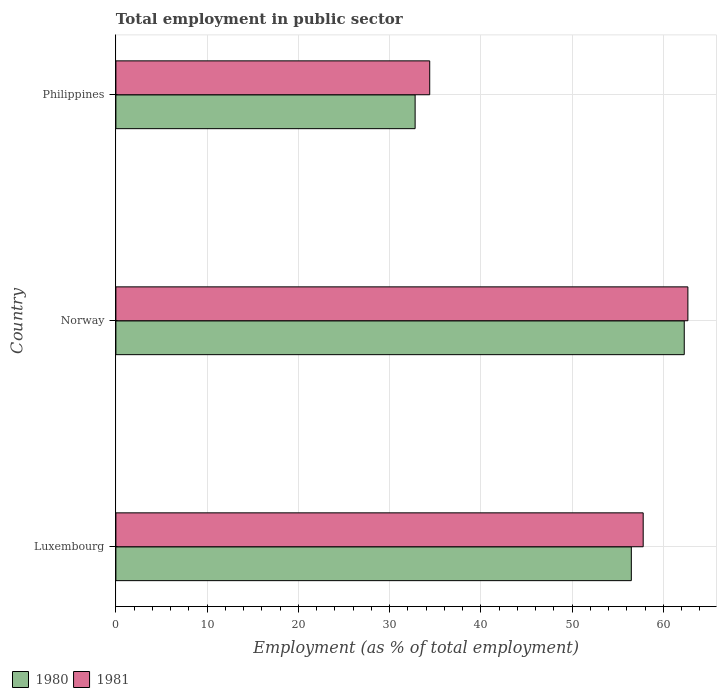How many groups of bars are there?
Give a very brief answer. 3. Are the number of bars per tick equal to the number of legend labels?
Keep it short and to the point. Yes. How many bars are there on the 1st tick from the top?
Keep it short and to the point. 2. How many bars are there on the 2nd tick from the bottom?
Your answer should be compact. 2. What is the label of the 3rd group of bars from the top?
Provide a short and direct response. Luxembourg. What is the employment in public sector in 1980 in Luxembourg?
Give a very brief answer. 56.5. Across all countries, what is the maximum employment in public sector in 1980?
Provide a short and direct response. 62.3. Across all countries, what is the minimum employment in public sector in 1981?
Offer a very short reply. 34.4. In which country was the employment in public sector in 1981 maximum?
Give a very brief answer. Norway. In which country was the employment in public sector in 1980 minimum?
Make the answer very short. Philippines. What is the total employment in public sector in 1981 in the graph?
Provide a succinct answer. 154.9. What is the difference between the employment in public sector in 1981 in Luxembourg and that in Norway?
Your answer should be very brief. -4.9. What is the difference between the employment in public sector in 1981 in Luxembourg and the employment in public sector in 1980 in Norway?
Provide a short and direct response. -4.5. What is the average employment in public sector in 1981 per country?
Offer a terse response. 51.63. What is the difference between the employment in public sector in 1980 and employment in public sector in 1981 in Philippines?
Offer a terse response. -1.6. What is the ratio of the employment in public sector in 1981 in Norway to that in Philippines?
Keep it short and to the point. 1.82. What is the difference between the highest and the second highest employment in public sector in 1981?
Offer a terse response. 4.9. What is the difference between the highest and the lowest employment in public sector in 1981?
Your answer should be very brief. 28.3. What does the 1st bar from the bottom in Philippines represents?
Provide a succinct answer. 1980. Are all the bars in the graph horizontal?
Give a very brief answer. Yes. How many countries are there in the graph?
Provide a short and direct response. 3. What is the difference between two consecutive major ticks on the X-axis?
Your answer should be compact. 10. Are the values on the major ticks of X-axis written in scientific E-notation?
Ensure brevity in your answer.  No. Does the graph contain any zero values?
Make the answer very short. No. Does the graph contain grids?
Offer a terse response. Yes. What is the title of the graph?
Keep it short and to the point. Total employment in public sector. What is the label or title of the X-axis?
Your response must be concise. Employment (as % of total employment). What is the label or title of the Y-axis?
Offer a terse response. Country. What is the Employment (as % of total employment) of 1980 in Luxembourg?
Keep it short and to the point. 56.5. What is the Employment (as % of total employment) in 1981 in Luxembourg?
Your response must be concise. 57.8. What is the Employment (as % of total employment) of 1980 in Norway?
Keep it short and to the point. 62.3. What is the Employment (as % of total employment) of 1981 in Norway?
Your answer should be compact. 62.7. What is the Employment (as % of total employment) of 1980 in Philippines?
Offer a terse response. 32.8. What is the Employment (as % of total employment) of 1981 in Philippines?
Keep it short and to the point. 34.4. Across all countries, what is the maximum Employment (as % of total employment) in 1980?
Provide a short and direct response. 62.3. Across all countries, what is the maximum Employment (as % of total employment) in 1981?
Provide a succinct answer. 62.7. Across all countries, what is the minimum Employment (as % of total employment) in 1980?
Offer a very short reply. 32.8. Across all countries, what is the minimum Employment (as % of total employment) of 1981?
Provide a succinct answer. 34.4. What is the total Employment (as % of total employment) in 1980 in the graph?
Provide a succinct answer. 151.6. What is the total Employment (as % of total employment) of 1981 in the graph?
Your response must be concise. 154.9. What is the difference between the Employment (as % of total employment) of 1980 in Luxembourg and that in Philippines?
Provide a succinct answer. 23.7. What is the difference between the Employment (as % of total employment) of 1981 in Luxembourg and that in Philippines?
Give a very brief answer. 23.4. What is the difference between the Employment (as % of total employment) of 1980 in Norway and that in Philippines?
Your response must be concise. 29.5. What is the difference between the Employment (as % of total employment) in 1981 in Norway and that in Philippines?
Your answer should be very brief. 28.3. What is the difference between the Employment (as % of total employment) of 1980 in Luxembourg and the Employment (as % of total employment) of 1981 in Norway?
Offer a very short reply. -6.2. What is the difference between the Employment (as % of total employment) of 1980 in Luxembourg and the Employment (as % of total employment) of 1981 in Philippines?
Your answer should be compact. 22.1. What is the difference between the Employment (as % of total employment) in 1980 in Norway and the Employment (as % of total employment) in 1981 in Philippines?
Your answer should be very brief. 27.9. What is the average Employment (as % of total employment) of 1980 per country?
Make the answer very short. 50.53. What is the average Employment (as % of total employment) of 1981 per country?
Make the answer very short. 51.63. What is the ratio of the Employment (as % of total employment) in 1980 in Luxembourg to that in Norway?
Keep it short and to the point. 0.91. What is the ratio of the Employment (as % of total employment) in 1981 in Luxembourg to that in Norway?
Make the answer very short. 0.92. What is the ratio of the Employment (as % of total employment) in 1980 in Luxembourg to that in Philippines?
Your answer should be very brief. 1.72. What is the ratio of the Employment (as % of total employment) of 1981 in Luxembourg to that in Philippines?
Offer a very short reply. 1.68. What is the ratio of the Employment (as % of total employment) of 1980 in Norway to that in Philippines?
Provide a short and direct response. 1.9. What is the ratio of the Employment (as % of total employment) of 1981 in Norway to that in Philippines?
Ensure brevity in your answer.  1.82. What is the difference between the highest and the lowest Employment (as % of total employment) in 1980?
Your answer should be very brief. 29.5. What is the difference between the highest and the lowest Employment (as % of total employment) in 1981?
Ensure brevity in your answer.  28.3. 